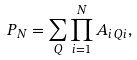Convert formula to latex. <formula><loc_0><loc_0><loc_500><loc_500>P _ { N } = \sum _ { Q } \prod _ { i = 1 } ^ { N } A _ { i \, Q i } ,</formula> 